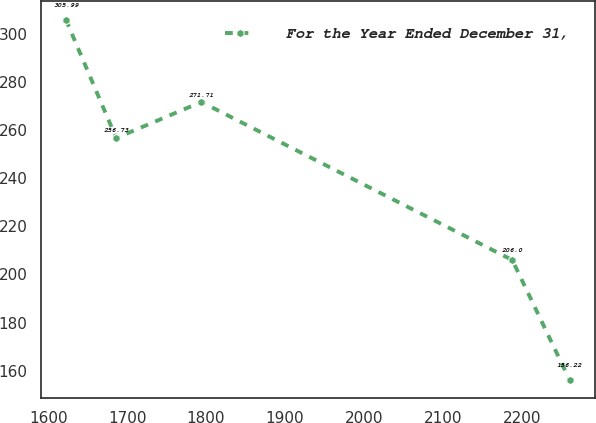Convert chart to OTSL. <chart><loc_0><loc_0><loc_500><loc_500><line_chart><ecel><fcel>For the Year Ended December 31,<nl><fcel>1622.39<fcel>305.99<nl><fcel>1686.22<fcel>256.73<nl><fcel>1794.15<fcel>271.71<nl><fcel>2188.14<fcel>206<nl><fcel>2260.68<fcel>156.22<nl></chart> 